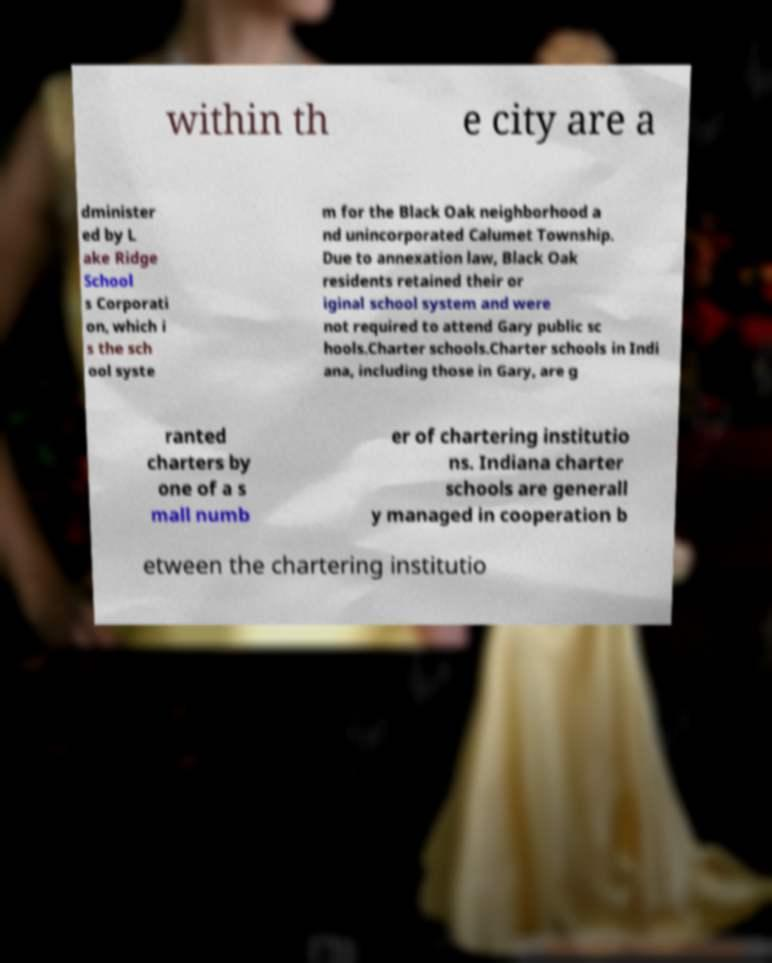For documentation purposes, I need the text within this image transcribed. Could you provide that? within th e city are a dminister ed by L ake Ridge School s Corporati on, which i s the sch ool syste m for the Black Oak neighborhood a nd unincorporated Calumet Township. Due to annexation law, Black Oak residents retained their or iginal school system and were not required to attend Gary public sc hools.Charter schools.Charter schools in Indi ana, including those in Gary, are g ranted charters by one of a s mall numb er of chartering institutio ns. Indiana charter schools are generall y managed in cooperation b etween the chartering institutio 